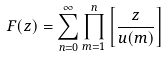Convert formula to latex. <formula><loc_0><loc_0><loc_500><loc_500>F ( z ) = \sum _ { n = 0 } ^ { \infty } \prod _ { m = 1 } ^ { n } \left [ \frac { z } { u ( m ) } \right ]</formula> 